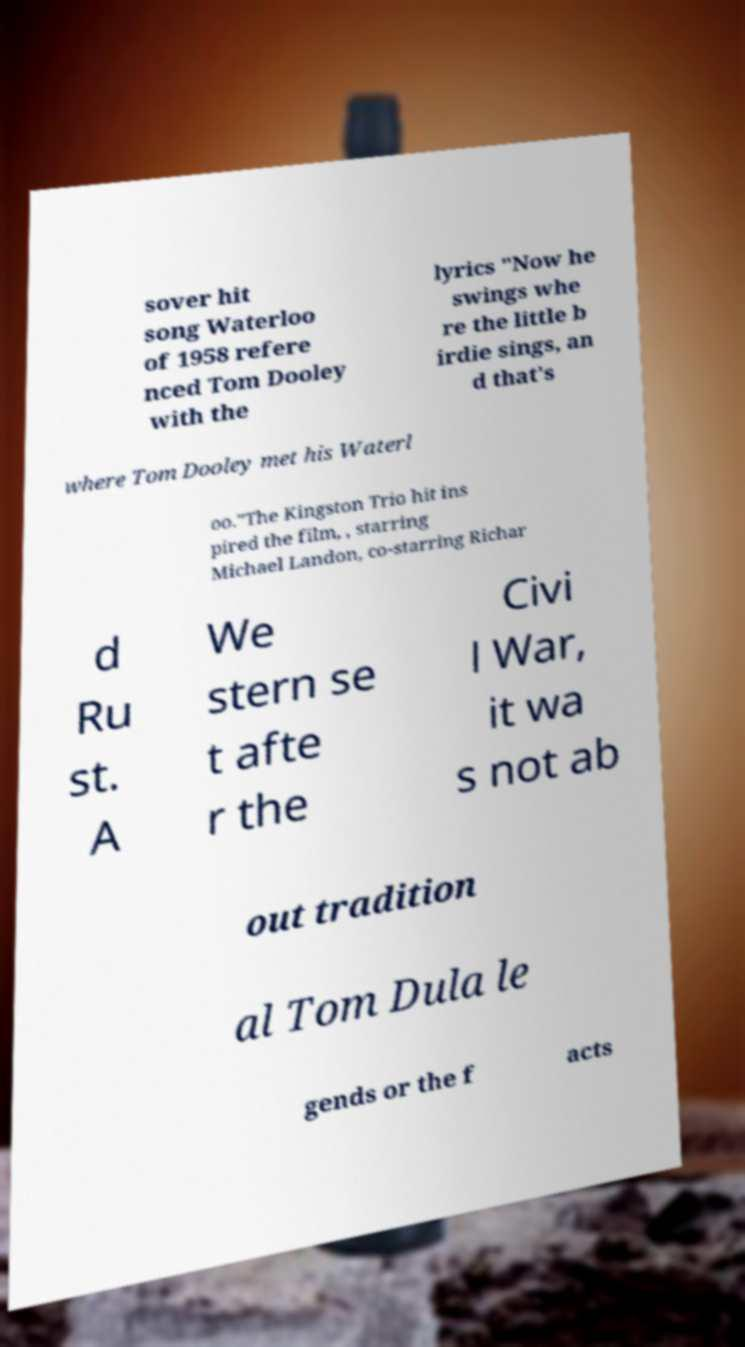For documentation purposes, I need the text within this image transcribed. Could you provide that? sover hit song Waterloo of 1958 refere nced Tom Dooley with the lyrics "Now he swings whe re the little b irdie sings, an d that's where Tom Dooley met his Waterl oo."The Kingston Trio hit ins pired the film, , starring Michael Landon, co-starring Richar d Ru st. A We stern se t afte r the Civi l War, it wa s not ab out tradition al Tom Dula le gends or the f acts 